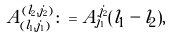Convert formula to latex. <formula><loc_0><loc_0><loc_500><loc_500>A _ { ( l _ { 1 } , j _ { 1 } ) } ^ { ( l _ { 2 } , j _ { 2 } ) } \colon = A _ { j _ { 1 } } ^ { j _ { 2 } } ( l _ { 1 } - l _ { 2 } ) ,</formula> 